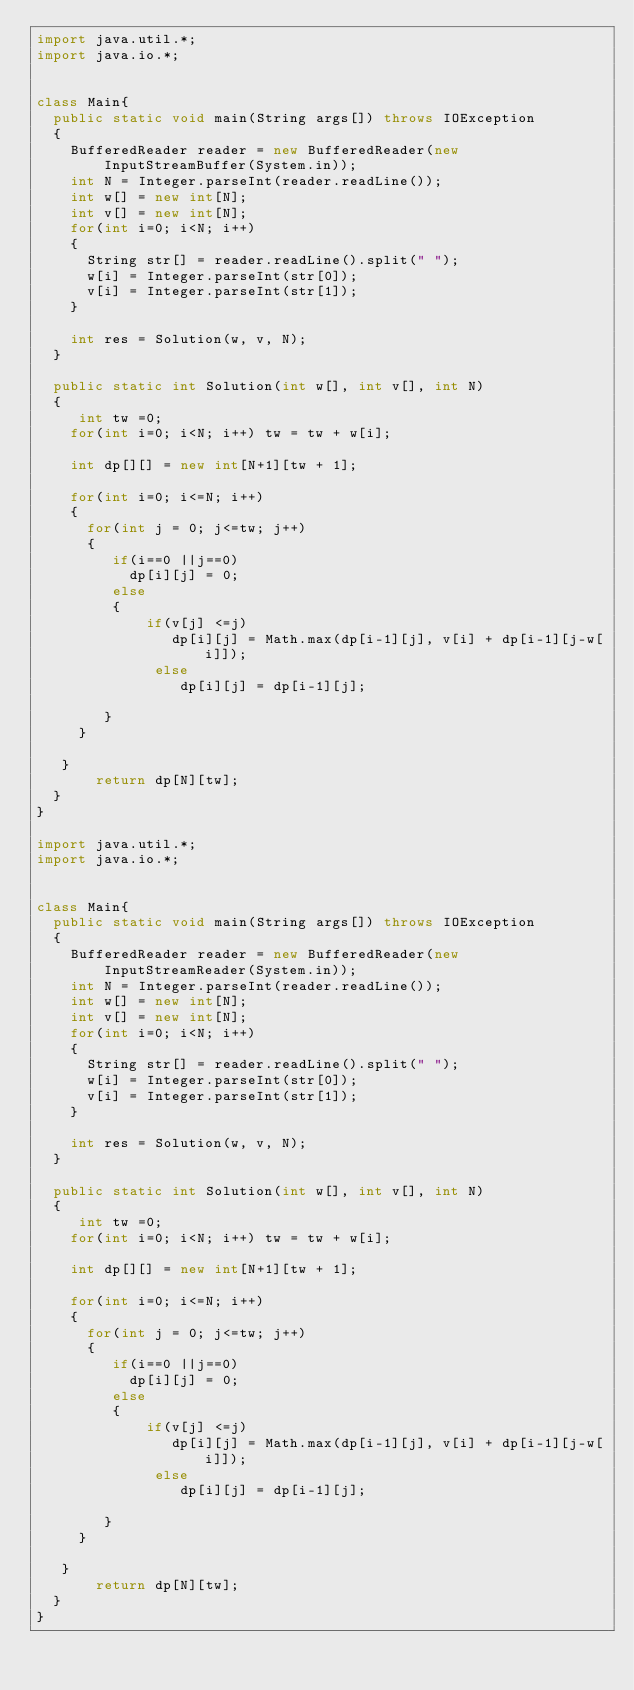Convert code to text. <code><loc_0><loc_0><loc_500><loc_500><_Java_>import java.util.*;
import java.io.*;
 
 
class Main{
  public static void main(String args[]) throws IOException
  {
    BufferedReader reader = new BufferedReader(new InputStreamBuffer(System.in));
    int N = Integer.parseInt(reader.readLine());
    int w[] = new int[N];
    int v[] = new int[N];
    for(int i=0; i<N; i++)
    {
      String str[] = reader.readLine().split(" ");
      w[i] = Integer.parseInt(str[0]);
      v[i] = Integer.parseInt(str[1]);
    }
    
    int res = Solution(w, v, N);
  }
  
  public static int Solution(int w[], int v[], int N)
  {
     int tw =0;
    for(int i=0; i<N; i++) tw = tw + w[i];
    
    int dp[][] = new int[N+1][tw + 1];
    
    for(int i=0; i<=N; i++)
    {
      for(int j = 0; j<=tw; j++)
      {
         if(i==0 ||j==0)
           dp[i][j] = 0;
         else
         {
             if(v[j] <=j)
                dp[i][j] = Math.max(dp[i-1][j], v[i] + dp[i-1][j-w[i]]);
              else
                 dp[i][j] = dp[i-1][j];
                                                               
        }                                                            
     }                                                      
                                                               
   }
       return dp[N][tw];
  }  
}
                   
import java.util.*;
import java.io.*;
 
 
class Main{
  public static void main(String args[]) throws IOException
  {
    BufferedReader reader = new BufferedReader(new InputStreamReader(System.in));
    int N = Integer.parseInt(reader.readLine());
    int w[] = new int[N];
    int v[] = new int[N];
    for(int i=0; i<N; i++)
    {
      String str[] = reader.readLine().split(" ");
      w[i] = Integer.parseInt(str[0]);
      v[i] = Integer.parseInt(str[1]);
    }
    
    int res = Solution(w, v, N);
  }
  
  public static int Solution(int w[], int v[], int N)
  {
     int tw =0;
    for(int i=0; i<N; i++) tw = tw + w[i];
    
    int dp[][] = new int[N+1][tw + 1];
    
    for(int i=0; i<=N; i++)
    {
      for(int j = 0; j<=tw; j++)
      {
         if(i==0 ||j==0)
           dp[i][j] = 0;
         else
         {
             if(v[j] <=j)
                dp[i][j] = Math.max(dp[i-1][j], v[i] + dp[i-1][j-w[i]]);
              else
                 dp[i][j] = dp[i-1][j];
                                                               
        }                                                            
     }                                                      
                                                               
   }
       return dp[N][tw];
  }  
}
                   </code> 